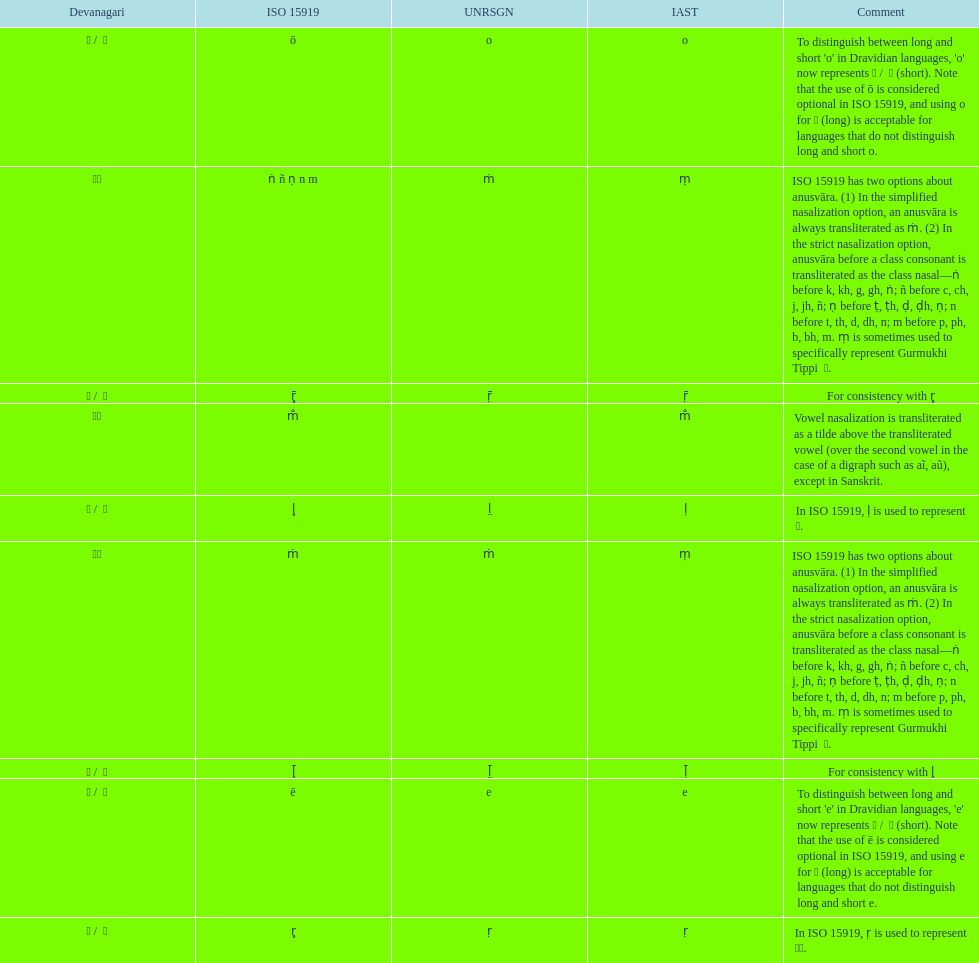Would you mind parsing the complete table? {'header': ['Devanagari', 'ISO 15919', 'UNRSGN', 'IAST', 'Comment'], 'rows': [['ओ / \xa0ो', 'ō', 'o', 'o', "To distinguish between long and short 'o' in Dravidian languages, 'o' now represents ऒ / \xa0ॊ (short). Note that the use of ō is considered optional in ISO 15919, and using o for ओ (long) is acceptable for languages that do not distinguish long and short o."], ['◌ं', 'ṅ ñ ṇ n m', 'ṁ', 'ṃ', 'ISO 15919 has two options about anusvāra. (1) In the simplified nasalization option, an anusvāra is always transliterated as ṁ. (2) In the strict nasalization option, anusvāra before a class consonant is transliterated as the class nasal—ṅ before k, kh, g, gh, ṅ; ñ before c, ch, j, jh, ñ; ṇ before ṭ, ṭh, ḍ, ḍh, ṇ; n before t, th, d, dh, n; m before p, ph, b, bh, m. ṃ is sometimes used to specifically represent Gurmukhi Tippi \xa0ੰ.'], ['ॠ / \xa0ॄ', 'r̥̄', 'ṝ', 'ṝ', 'For consistency with r̥'], ['◌ँ', 'm̐', '', 'm̐', 'Vowel nasalization is transliterated as a tilde above the transliterated vowel (over the second vowel in the case of a digraph such as aĩ, aũ), except in Sanskrit.'], ['ऌ / \xa0ॢ', 'l̥', 'l̤', 'ḷ', 'In ISO 15919, ḷ is used to represent ळ.'], ['◌ं', 'ṁ', 'ṁ', 'ṃ', 'ISO 15919 has two options about anusvāra. (1) In the simplified nasalization option, an anusvāra is always transliterated as ṁ. (2) In the strict nasalization option, anusvāra before a class consonant is transliterated as the class nasal—ṅ before k, kh, g, gh, ṅ; ñ before c, ch, j, jh, ñ; ṇ before ṭ, ṭh, ḍ, ḍh, ṇ; n before t, th, d, dh, n; m before p, ph, b, bh, m. ṃ is sometimes used to specifically represent Gurmukhi Tippi \xa0ੰ.'], ['ॡ / \xa0ॣ', 'l̥̄', 'l̤̄', 'ḹ', 'For consistency with l̥'], ['ए / \xa0े', 'ē', 'e', 'e', "To distinguish between long and short 'e' in Dravidian languages, 'e' now represents ऎ / \xa0ॆ (short). Note that the use of ē is considered optional in ISO 15919, and using e for ए (long) is acceptable for languages that do not distinguish long and short e."], ['ऋ / \xa0ृ', 'r̥', 'ṛ', 'ṛ', 'In ISO 15919, ṛ is used to represent ड़.']]} How many total options are there about anusvara? 2. 